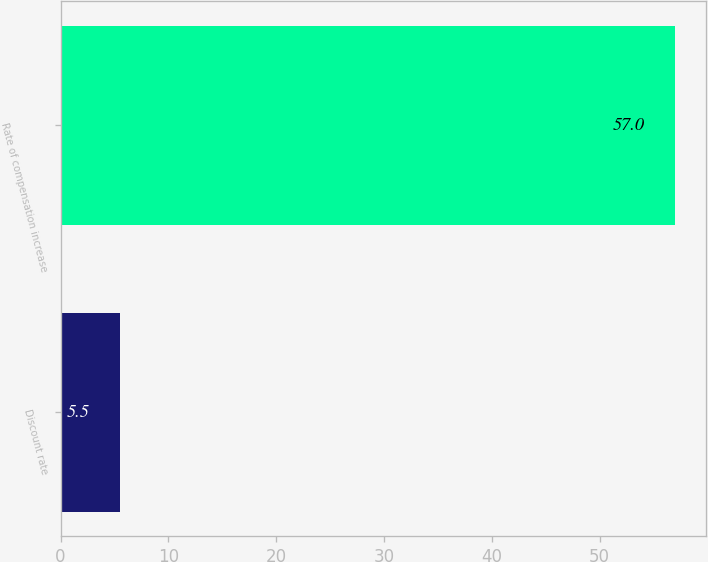Convert chart. <chart><loc_0><loc_0><loc_500><loc_500><bar_chart><fcel>Discount rate<fcel>Rate of compensation increase<nl><fcel>5.5<fcel>57<nl></chart> 